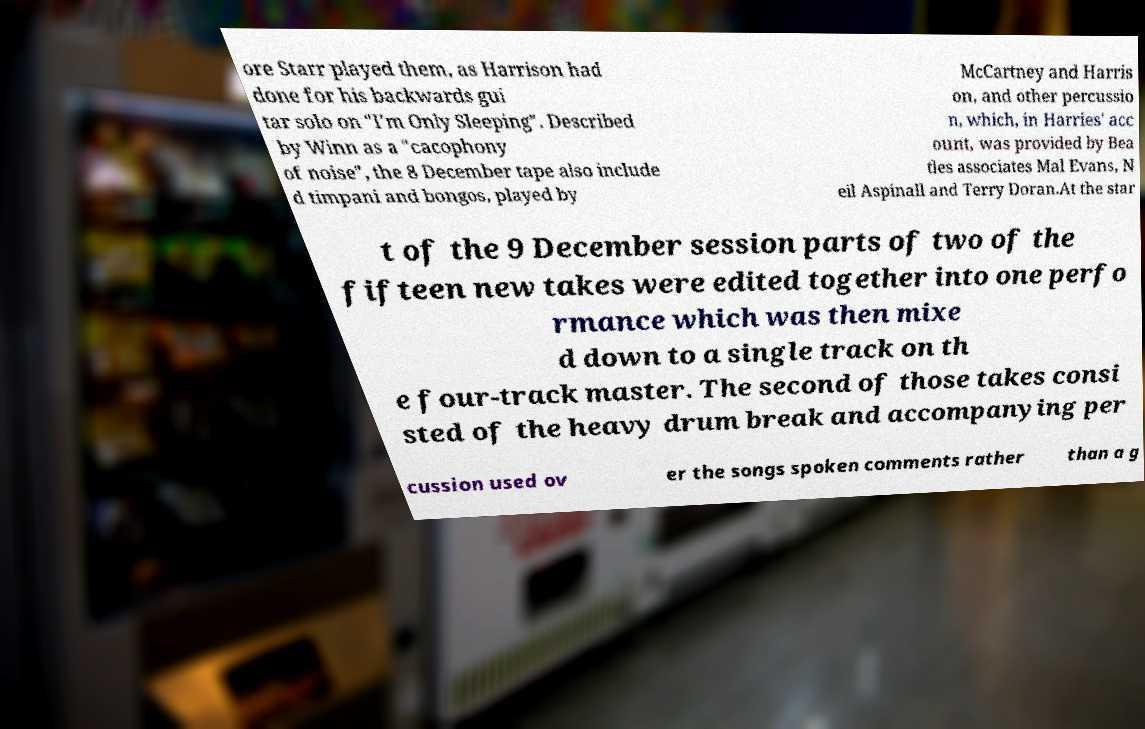Can you read and provide the text displayed in the image?This photo seems to have some interesting text. Can you extract and type it out for me? ore Starr played them, as Harrison had done for his backwards gui tar solo on "I'm Only Sleeping". Described by Winn as a "cacophony of noise", the 8 December tape also include d timpani and bongos, played by McCartney and Harris on, and other percussio n, which, in Harries' acc ount, was provided by Bea tles associates Mal Evans, N eil Aspinall and Terry Doran.At the star t of the 9 December session parts of two of the fifteen new takes were edited together into one perfo rmance which was then mixe d down to a single track on th e four-track master. The second of those takes consi sted of the heavy drum break and accompanying per cussion used ov er the songs spoken comments rather than a g 